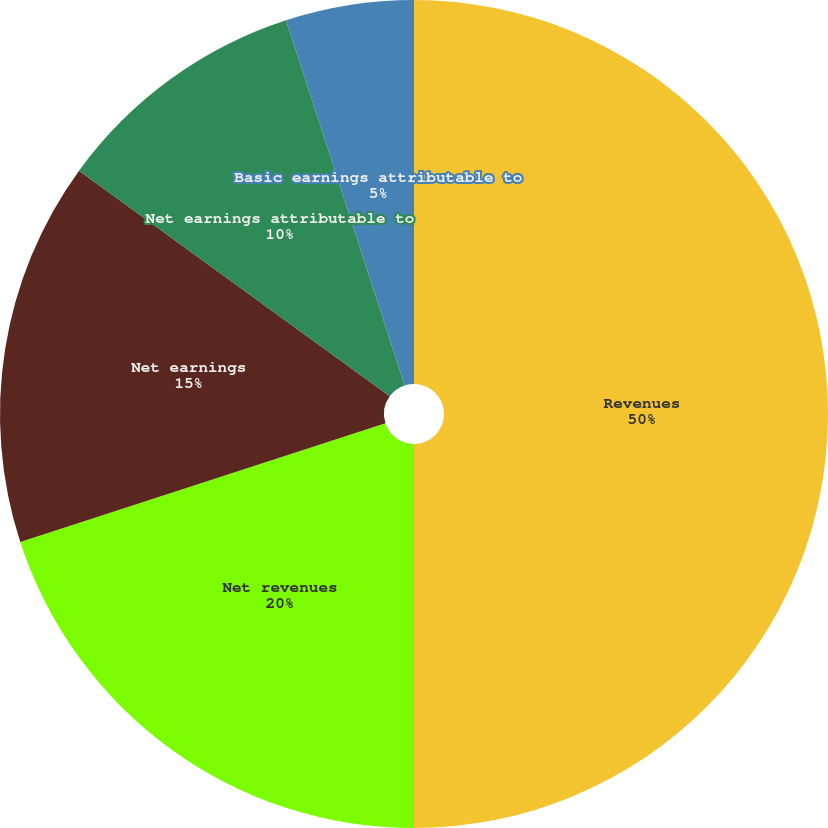Convert chart to OTSL. <chart><loc_0><loc_0><loc_500><loc_500><pie_chart><fcel>Revenues<fcel>Net revenues<fcel>Net earnings<fcel>Net earnings attributable to<fcel>Diluted earnings attributable<fcel>Basic earnings attributable to<nl><fcel>50.0%<fcel>20.0%<fcel>15.0%<fcel>10.0%<fcel>0.0%<fcel>5.0%<nl></chart> 